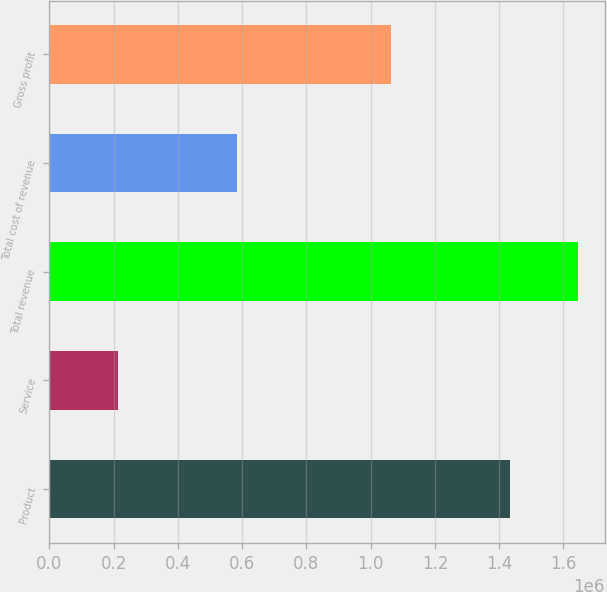<chart> <loc_0><loc_0><loc_500><loc_500><bar_chart><fcel>Product<fcel>Service<fcel>Total revenue<fcel>Total cost of revenue<fcel>Gross profit<nl><fcel>1.43281e+06<fcel>213376<fcel>1.64619e+06<fcel>584417<fcel>1.06177e+06<nl></chart> 